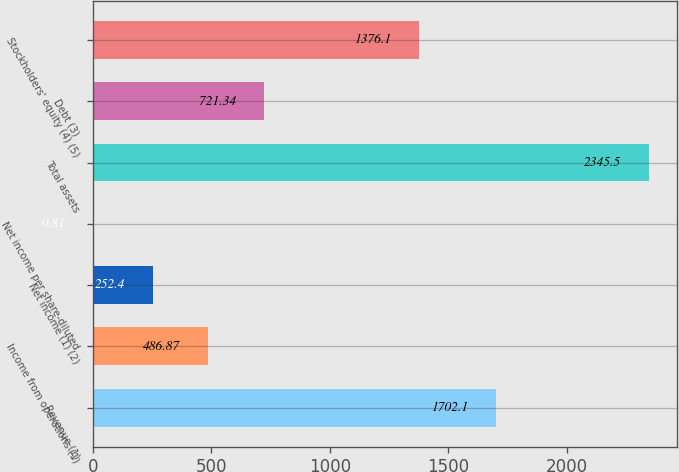Convert chart to OTSL. <chart><loc_0><loc_0><loc_500><loc_500><bar_chart><fcel>Revenue (1)<fcel>Income from operations (1)<fcel>Net income (1) (2)<fcel>Net income per share-diluted<fcel>Total assets<fcel>Debt (3)<fcel>Stockholders' equity (4) (5)<nl><fcel>1702.1<fcel>486.87<fcel>252.4<fcel>0.81<fcel>2345.5<fcel>721.34<fcel>1376.1<nl></chart> 